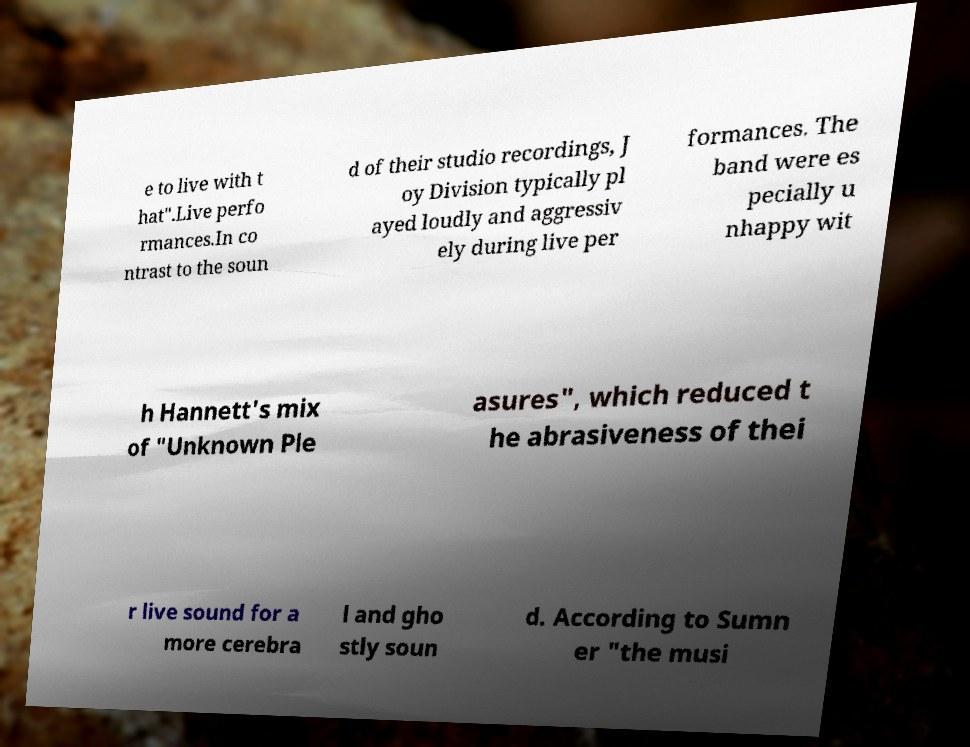Can you read and provide the text displayed in the image?This photo seems to have some interesting text. Can you extract and type it out for me? e to live with t hat".Live perfo rmances.In co ntrast to the soun d of their studio recordings, J oy Division typically pl ayed loudly and aggressiv ely during live per formances. The band were es pecially u nhappy wit h Hannett's mix of "Unknown Ple asures", which reduced t he abrasiveness of thei r live sound for a more cerebra l and gho stly soun d. According to Sumn er "the musi 